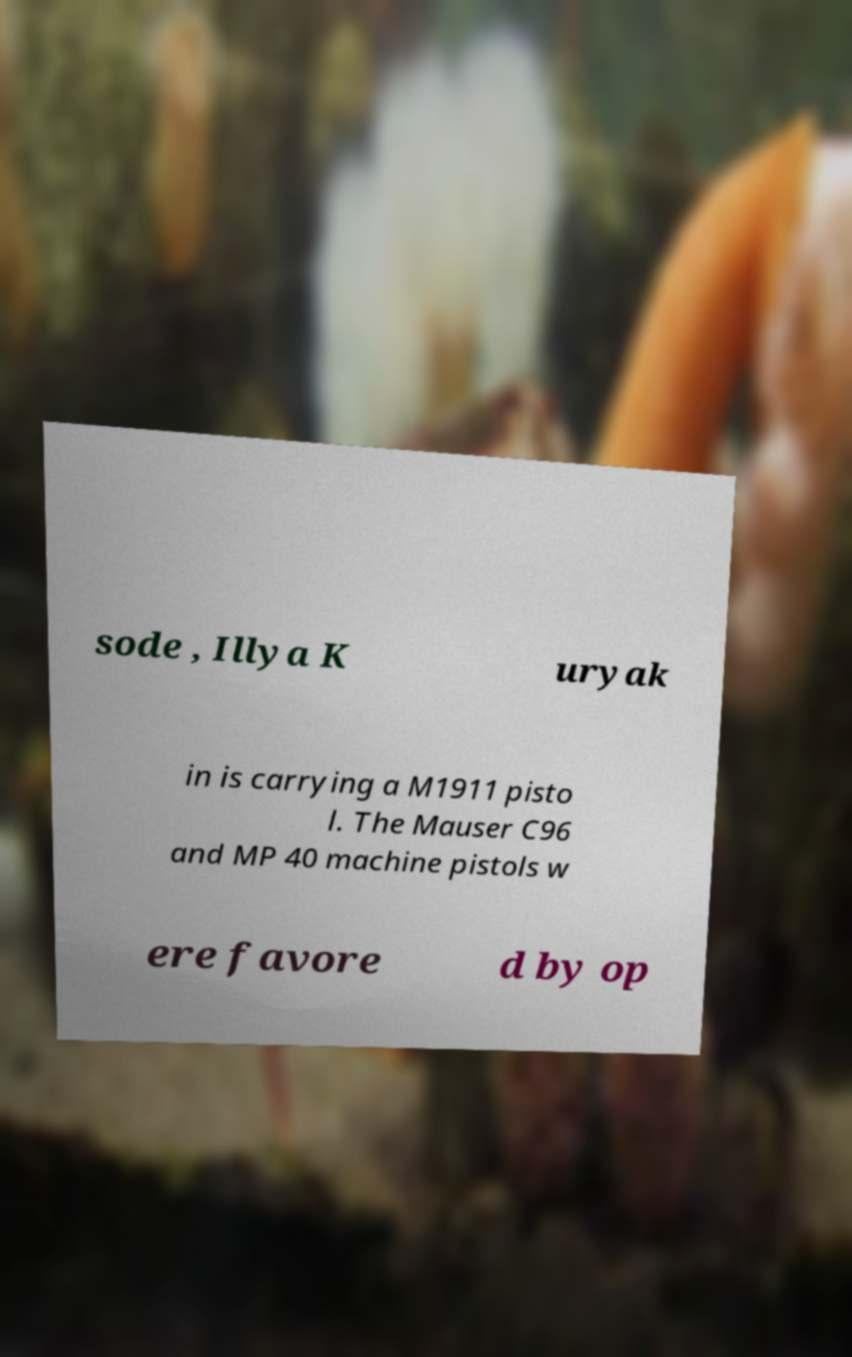Could you assist in decoding the text presented in this image and type it out clearly? sode , Illya K uryak in is carrying a M1911 pisto l. The Mauser C96 and MP 40 machine pistols w ere favore d by op 